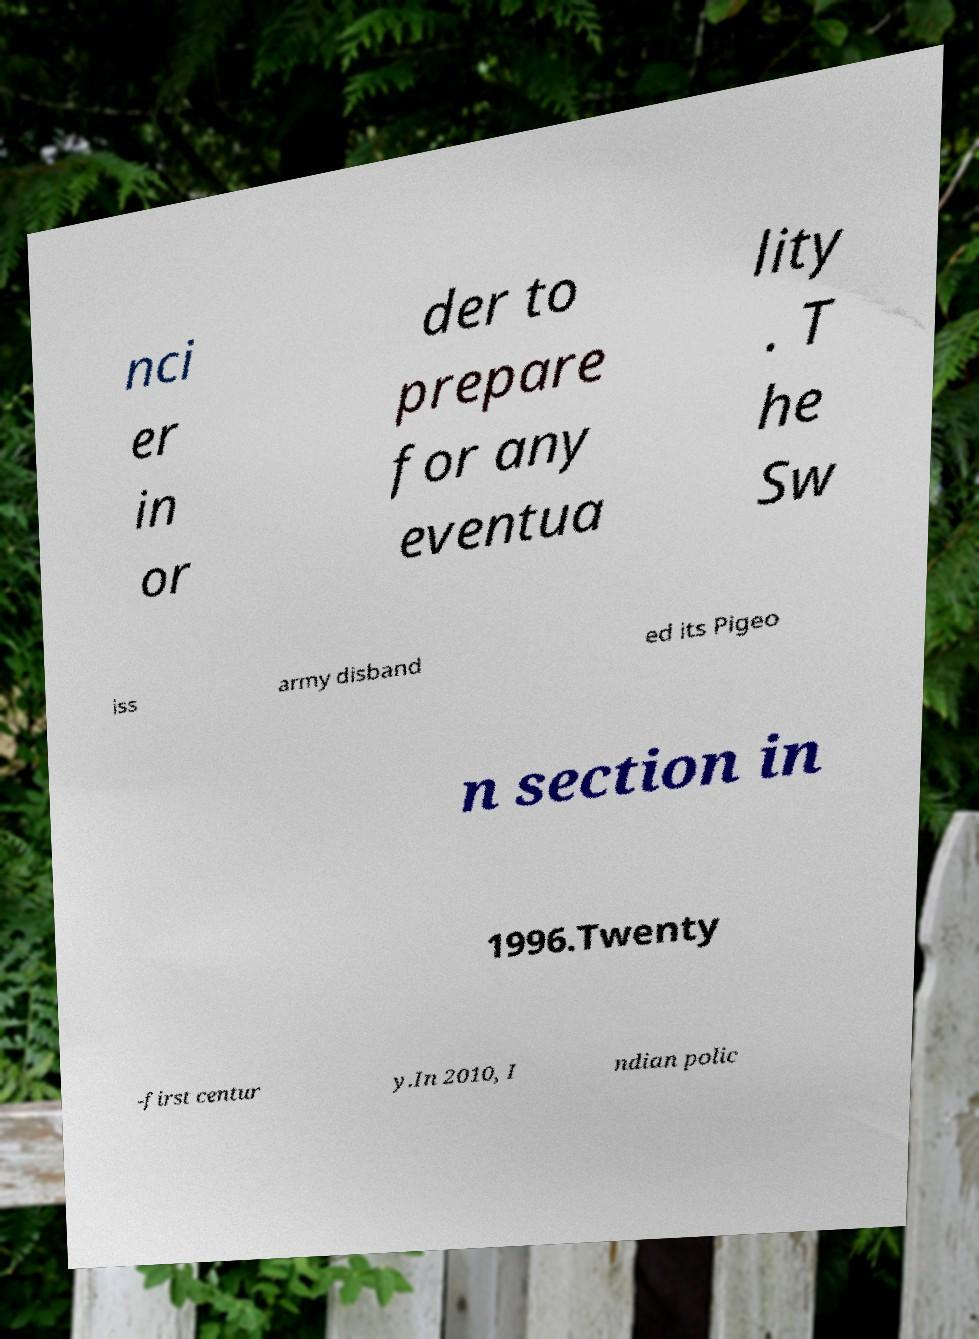I need the written content from this picture converted into text. Can you do that? nci er in or der to prepare for any eventua lity . T he Sw iss army disband ed its Pigeo n section in 1996.Twenty -first centur y.In 2010, I ndian polic 